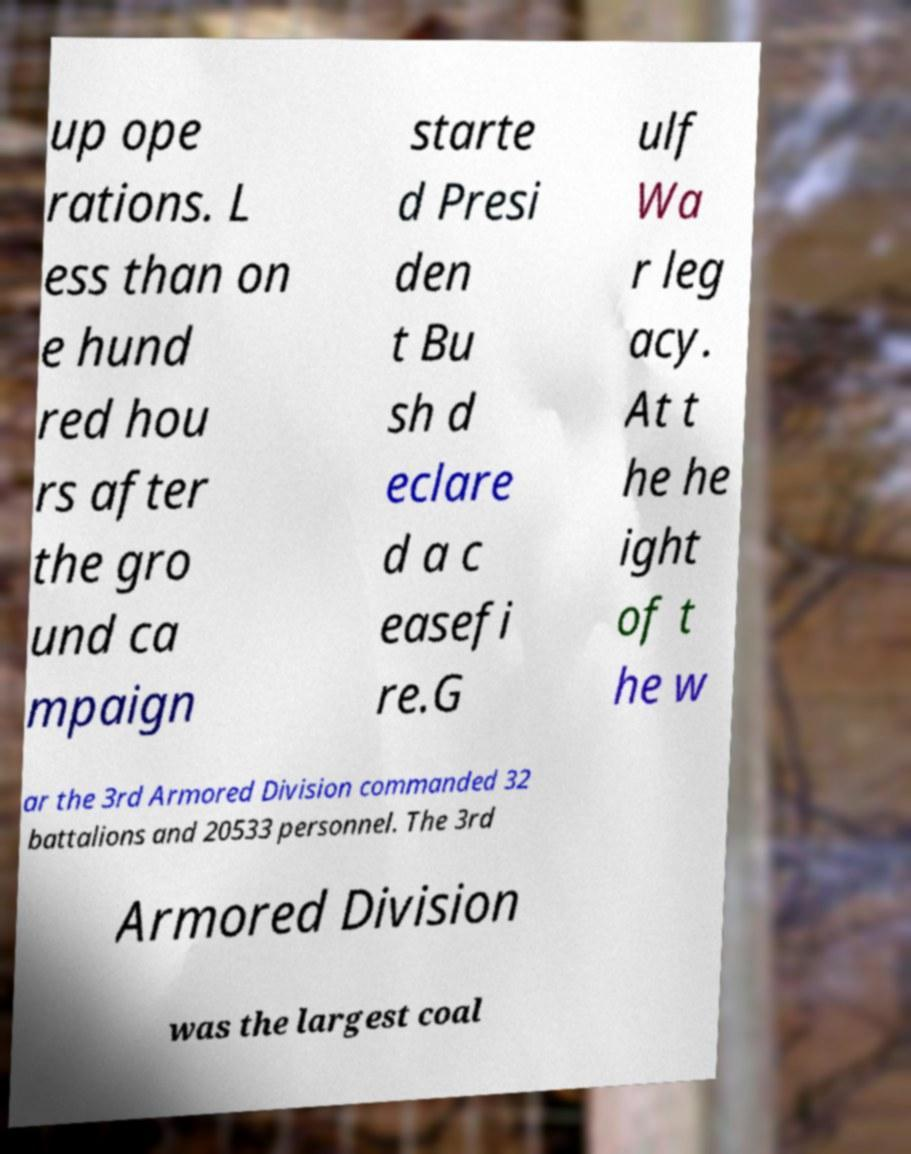Can you read and provide the text displayed in the image?This photo seems to have some interesting text. Can you extract and type it out for me? up ope rations. L ess than on e hund red hou rs after the gro und ca mpaign starte d Presi den t Bu sh d eclare d a c easefi re.G ulf Wa r leg acy. At t he he ight of t he w ar the 3rd Armored Division commanded 32 battalions and 20533 personnel. The 3rd Armored Division was the largest coal 